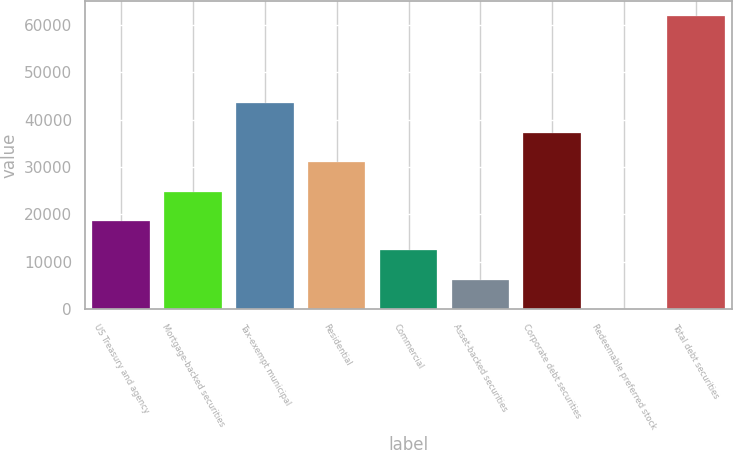Convert chart to OTSL. <chart><loc_0><loc_0><loc_500><loc_500><bar_chart><fcel>US Treasury and agency<fcel>Mortgage-backed securities<fcel>Tax-exempt municipal<fcel>Residential<fcel>Commercial<fcel>Asset-backed securities<fcel>Corporate debt securities<fcel>Redeemable preferred stock<fcel>Total debt securities<nl><fcel>18603<fcel>24803.6<fcel>43619<fcel>31004.1<fcel>12402.4<fcel>6201.85<fcel>37204.7<fcel>1.28<fcel>62007<nl></chart> 